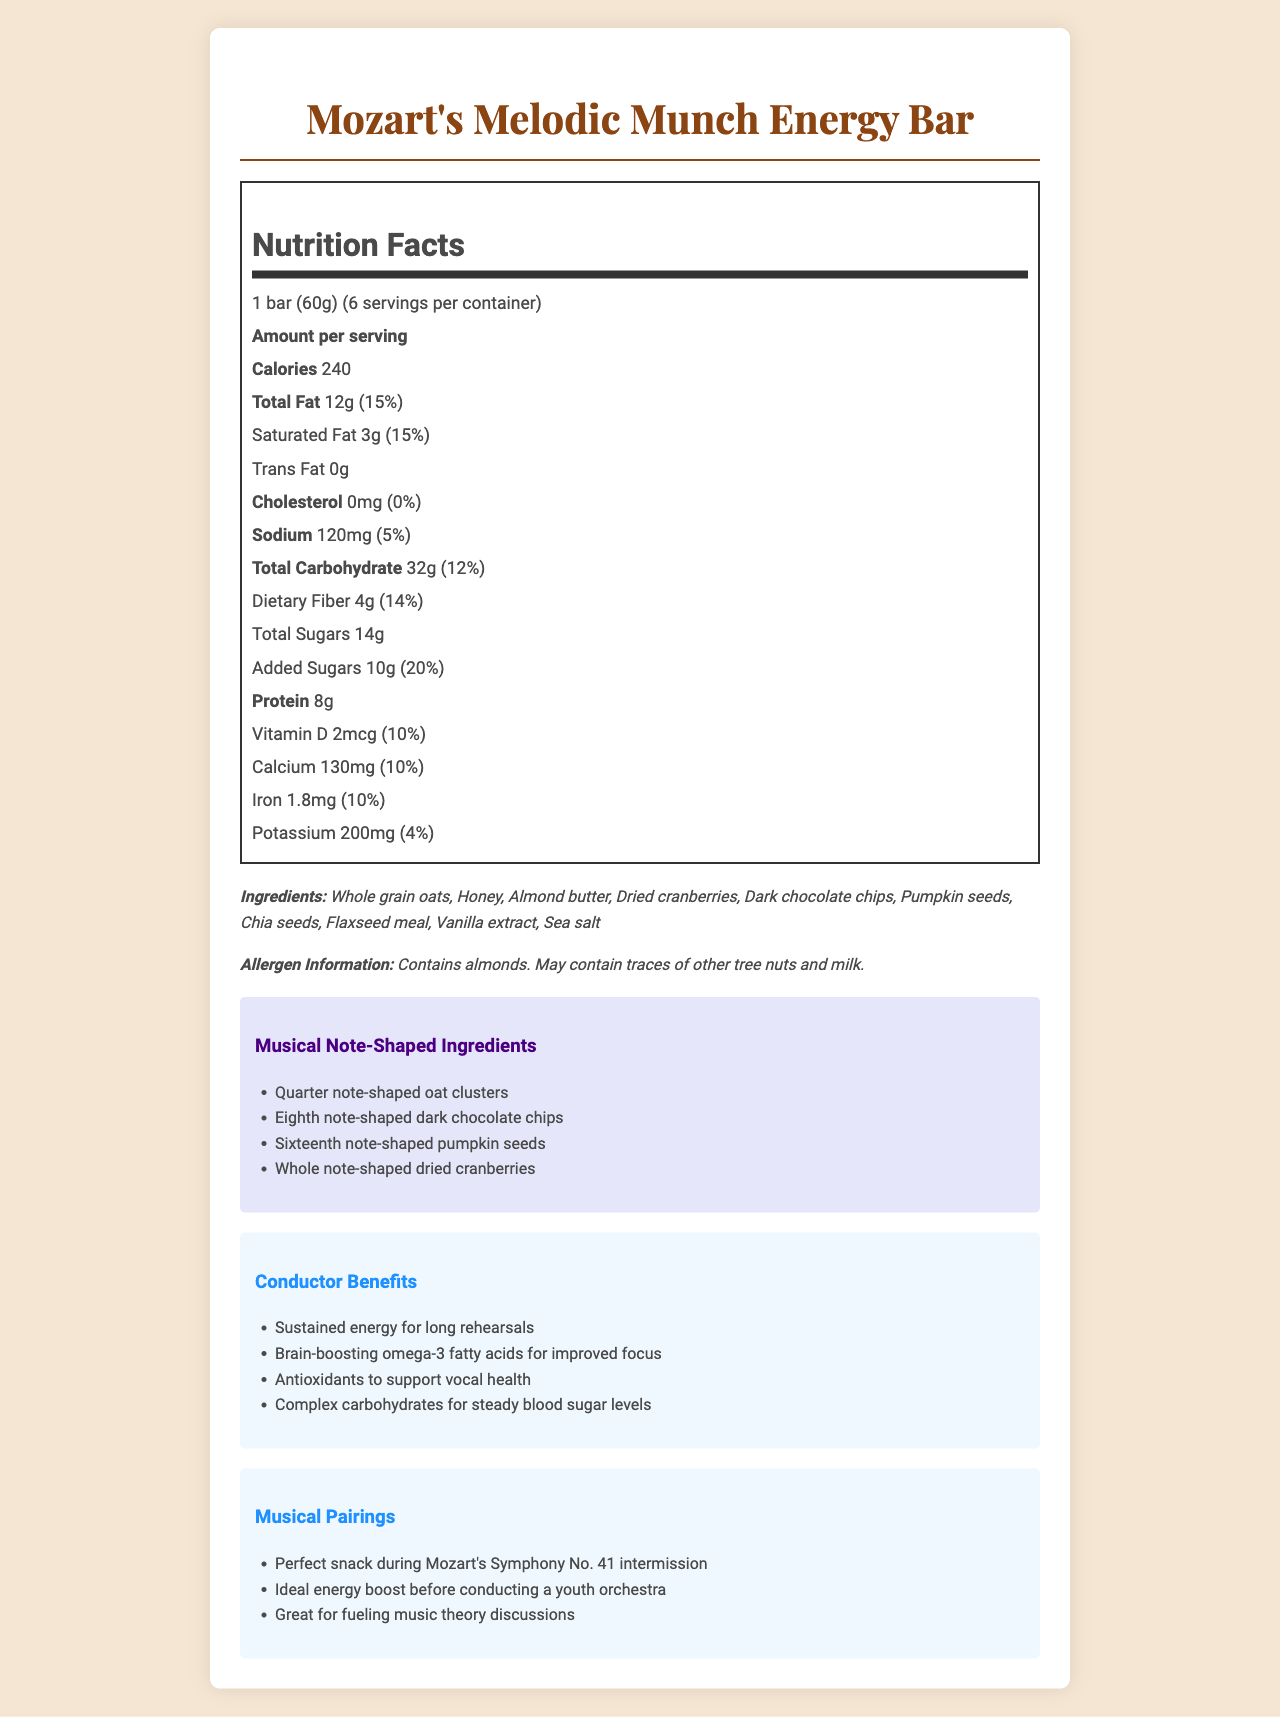what is the serving size? The serving size is clearly stated as "1 bar (60g)" in the Nutrition Facts section.
Answer: 1 bar (60g) how many servings are there per container? The document lists "6 servings per container" in the Nutrition Facts section.
Answer: 6 how much protein is in one bar? The amount of protein per serving is listed as 8g in the Nutrition Facts section.
Answer: 8g what is the amount of total fat per serving? The amount of total fat per serving is indicated as 12g in the Nutrition Facts section.
Answer: 12g which ingredient in the bar is shaped like a whole note? The document specifies that the "Whole note-shaped dried cranberries" are one of the musical note-shaped ingredients.
Answer: Dried cranberries how much Vitamin D is in one serving? The amount of Vitamin D per serving is listed as 2mcg in the Nutrition Facts section.
Answer: 2mcg how many calories are there per bar? The document states that each bar contains 240 calories.
Answer: 240 what are the main benefits for conductors consuming this energy bar? (Choose all that apply) A. Sustained energy B. Supports vocal health C. Boosts immune system D. Improves focus The conductor benefits mentioned are: "Sustained energy for long rehearsals," "Brain-boosting omega-3 fatty acids for improved focus," and "Antioxidants to support vocal health."
Answer: A, B, D which ingredient provides omega-3 fatty acids? A. Whole grain oats B. Chia seeds C. Almond butter D. Dark chocolate chips The document mentions "Brain-boosting omega-3 fatty acids," which are found in chia seeds.
Answer: B is the bar suitable for someone allergic to milk? The allergen information states the product "May contain traces of other tree nuts and milk."
Answer: No summarize the main content of the document. The document comprehensively covers nutritional facts, ingredients, allergens, special features, health benefits, and recommended contexts for enjoying the energy bar.
Answer: The document provides detailed nutritional information for Mozart's Melodic Munch Energy Bar. It includes the serving size, number of servings per container, calories, and breakdown of fats, cholesterol, sodium, carbohydrates, sugars, protein, vitamins, and minerals. It also lists ingredients, allergen information, unique musical note-shaped ingredients, benefits for conductors, and suggested musical pairings. does the bar contain trans fat? The Nutrition Facts section lists "Trans Fat 0g."
Answer: No how much added sugar is in one bar? The document specifies that there are 10g of added sugars per serving.
Answer: 10g can we determine the production date of the bar from the document? The document does not provide any information regarding the production or expiration dates of the energy bar.
Answer: Cannot be determined 